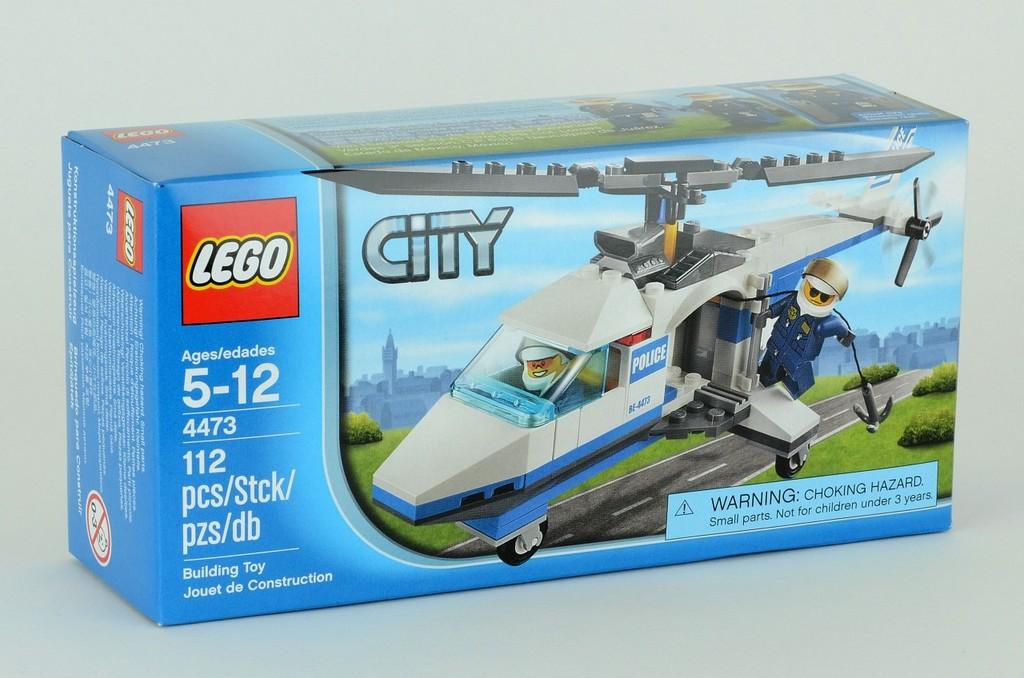What brand of building block is this?
Provide a succinct answer. Lego. What ages does it say it's for?
Offer a very short reply. 5-12. 